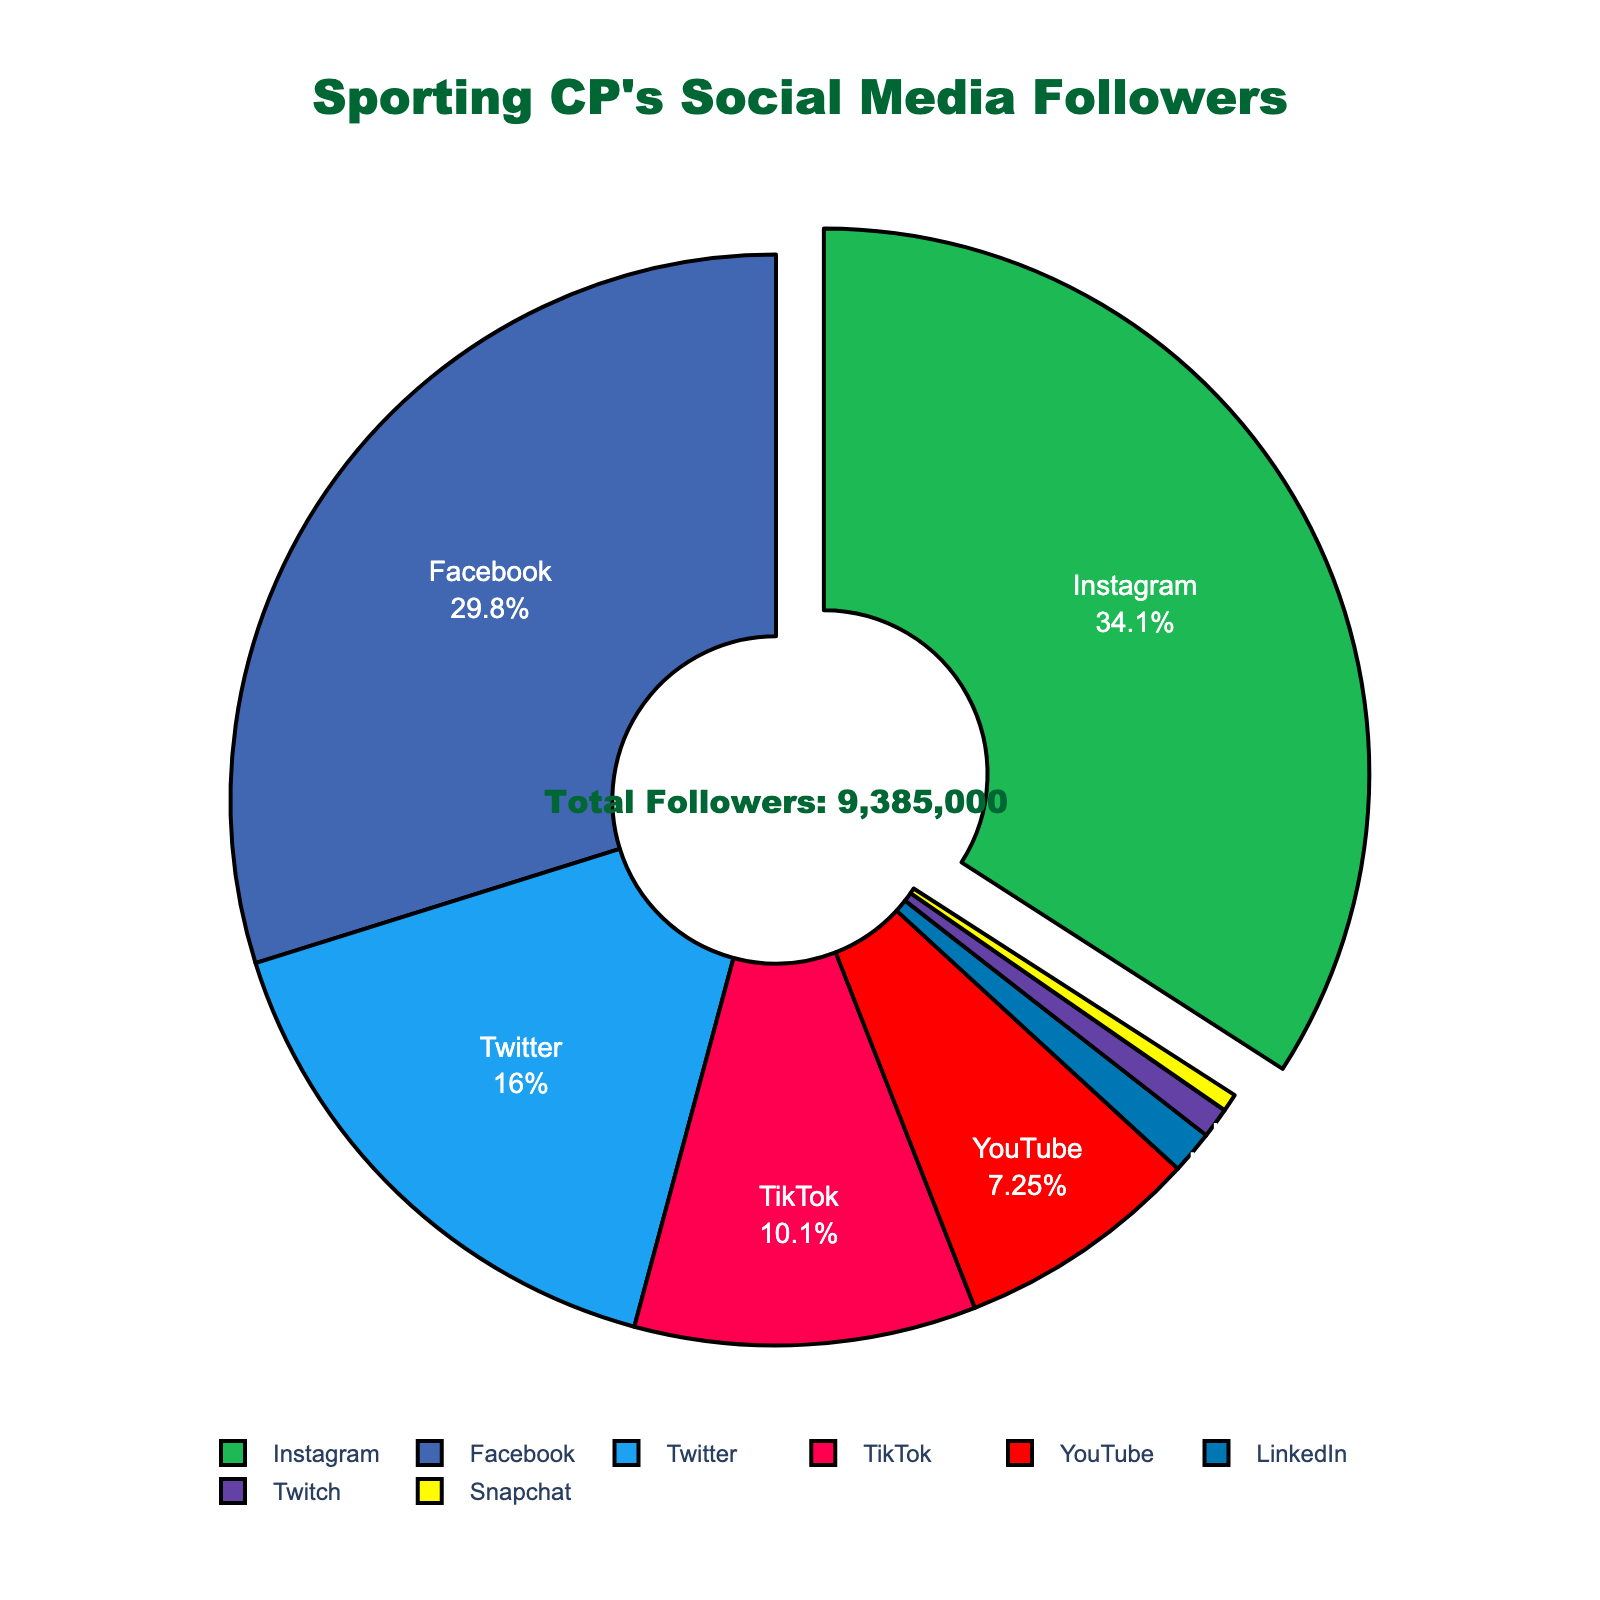What percentage of Sporting CP’s social media followers are on Instagram? Instagram's portion is indicated on the chart with a percentage, showing that 39.81% of followers are on Instagram.
Answer: 39.81% Which platform has the lowest number of followers? By examining the pie chart, the smallest segment is for Snapchat, indicating it has the lowest number of followers.
Answer: Snapchat How many more followers does Instagram have compared to Twitter? Instagram has 3,200,000 followers and Twitter has 1,500,000 followers. The difference is 3,200,000 - 1,500,000.
Answer: 1,700,000 What is the combined percentage of followers on Facebook and YouTube? From the pie chart, Facebook has 34.83% and YouTube has 8.46%. Adding these percentages gives 34.83% + 8.46%.
Answer: 43.29% What color represents TikTok on the pie chart? TikTok is represented by the color red on the pie chart.
Answer: Red How does the number of LinkedIn followers compare to those on Twitch? The chart shows LinkedIn with 120,000 followers and Twitch with 85,000 followers. LinkedIn has more followers than Twitch.
Answer: LinkedIn has more followers Which four platforms have the highest number of followers? The largest segments in the pie chart indicate the platforms with the highest followers: Instagram, Facebook, Twitter, and TikTok.
Answer: Instagram, Facebook, Twitter, TikTok What is the total number of social media followers represented in the chart? According to the annotation in the center of the pie chart, the total number of followers is 8,555,000.
Answer: 8,555,000 What percentage of Sporting CP’s social media followers are on the combined platforms of Facebook, Twitter, and TikTok? From the pie chart, Facebook has 34.83%, Twitter has 17.53%, and TikTok has 11.10%. Adding these percentages gives 34.83% + 17.53% + 11.10%.
Answer: 63.46% Which platform's segment is pulled out slightly from the pie? The pie chart illustrates that the Instagram segment is pulled out slightly.
Answer: Instagram 